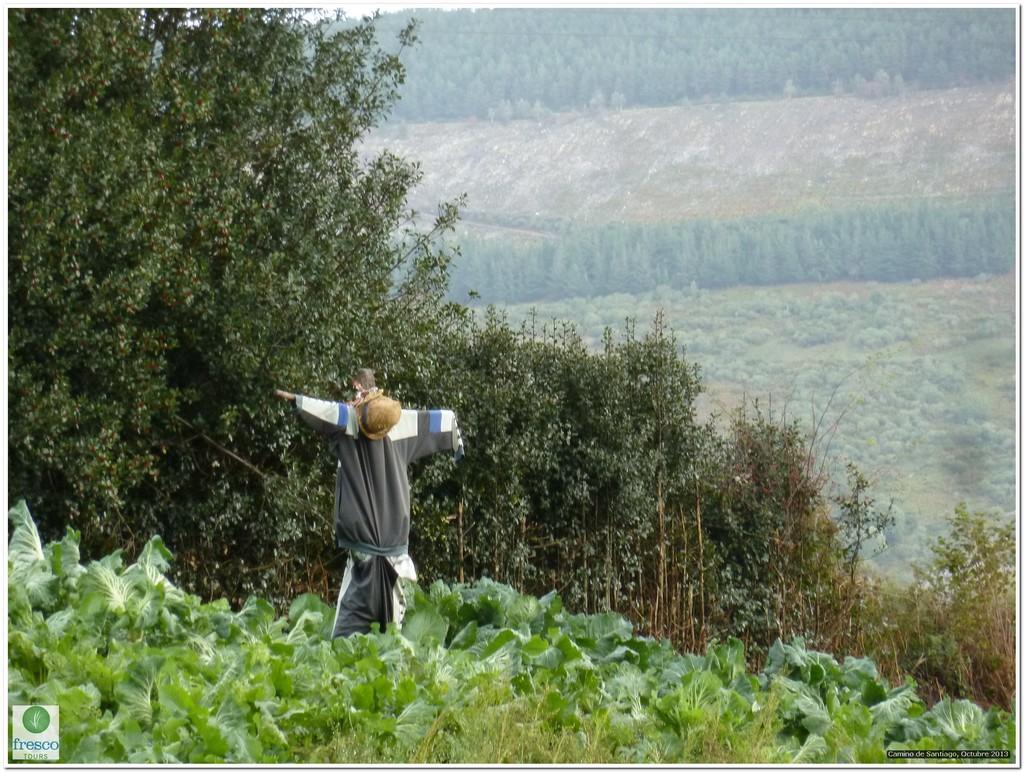Please provide a concise description of this image. In the center of the image we can see clothes and a hat on some object. At the bottom left side of the image, there is a logo. In the background, we can see trees and plants. 